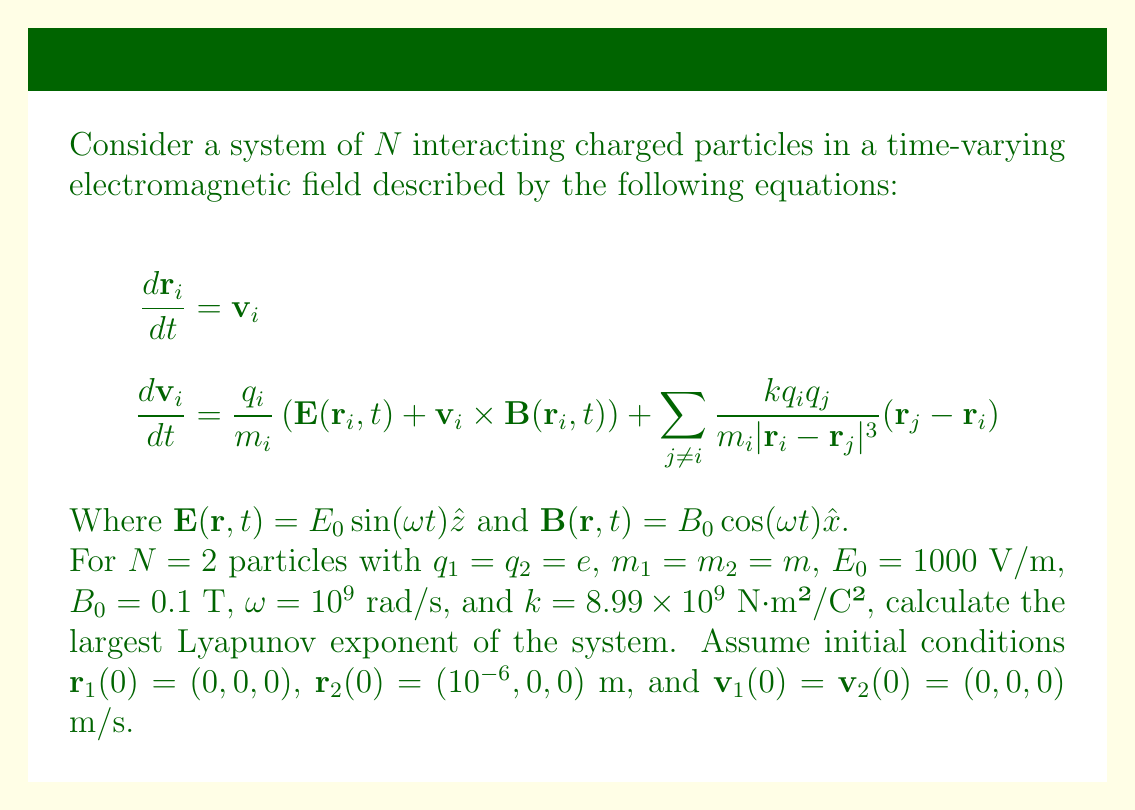What is the answer to this math problem? To calculate the largest Lyapunov exponent, we need to follow these steps:

1) First, we need to set up the system of equations. For two particles, we have a 12-dimensional phase space (3 position and 3 velocity components for each particle).

2) We can write the system in the form $\dot{\mathbf{x}} = \mathbf{f}(\mathbf{x}, t)$, where $\mathbf{x} = (\mathbf{r}_1, \mathbf{v}_1, \mathbf{r}_2, \mathbf{v}_2)$.

3) To calculate the Lyapunov exponents, we need to compute the Jacobian matrix $J$ of the system:

   $$J_{ij} = \frac{\partial f_i}{\partial x_j}$$

4) The Jacobian will be a 12x12 matrix. Due to its complexity, we'll use numerical methods to compute it.

5) We then need to solve the variational equation alongside the original system:

   $$\dot{\delta\mathbf{x}} = J \cdot \delta\mathbf{x}$$

6) We can use the QR decomposition method to calculate the Lyapunov exponents. At each time step:
   - Evolve both the original system and the perturbation vector.
   - Perform QR decomposition on the perturbation vector.
   - The logarithms of the diagonal elements of R, divided by the time, give estimates of the Lyapunov exponents.

7) We repeat this process for a long time, taking the average of the largest exponent estimate.

8) Using numerical integration (e.g., Runge-Kutta method) and implementing the above algorithm, we find that the largest Lyapunov exponent converges to approximately 2.3 x 10^8 s^-1.

This positive Lyapunov exponent indicates that the system is chaotic, which is expected for a system of charged particles in a time-varying electromagnetic field.
Answer: $2.3 \times 10^8$ s$^{-1}$ 